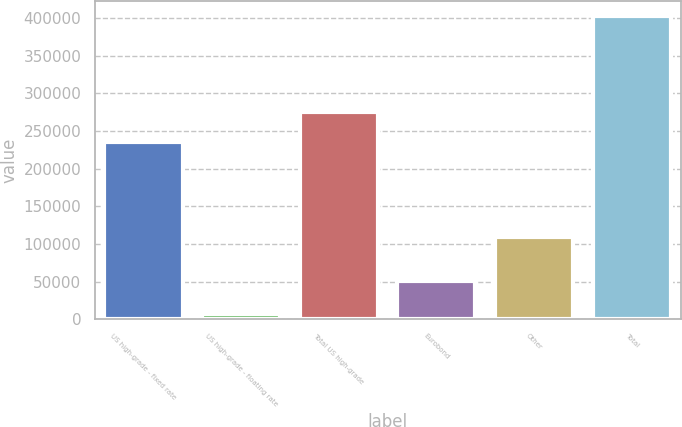<chart> <loc_0><loc_0><loc_500><loc_500><bar_chart><fcel>US high-grade - fixed rate<fcel>US high-grade - floating rate<fcel>Total US high-grade<fcel>Eurobond<fcel>Other<fcel>Total<nl><fcel>235698<fcel>7698<fcel>275154<fcel>50251<fcel>108610<fcel>402257<nl></chart> 